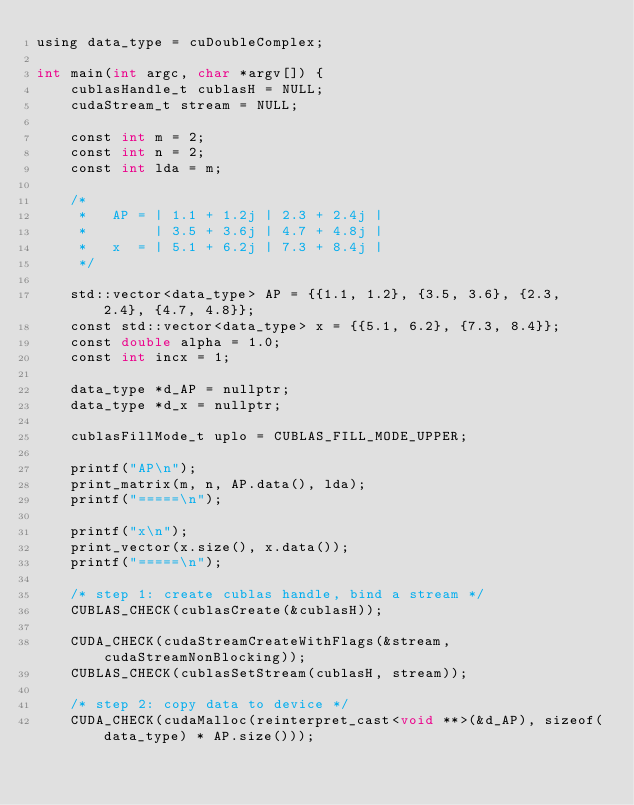Convert code to text. <code><loc_0><loc_0><loc_500><loc_500><_Cuda_>using data_type = cuDoubleComplex;

int main(int argc, char *argv[]) {
    cublasHandle_t cublasH = NULL;
    cudaStream_t stream = NULL;

    const int m = 2;
    const int n = 2;
    const int lda = m;

    /*
     *   AP = | 1.1 + 1.2j | 2.3 + 2.4j |
     *        | 3.5 + 3.6j | 4.7 + 4.8j |
     *   x  = | 5.1 + 6.2j | 7.3 + 8.4j |
     */

    std::vector<data_type> AP = {{1.1, 1.2}, {3.5, 3.6}, {2.3, 2.4}, {4.7, 4.8}};
    const std::vector<data_type> x = {{5.1, 6.2}, {7.3, 8.4}};
    const double alpha = 1.0;
    const int incx = 1;

    data_type *d_AP = nullptr;
    data_type *d_x = nullptr;

    cublasFillMode_t uplo = CUBLAS_FILL_MODE_UPPER;

    printf("AP\n");
    print_matrix(m, n, AP.data(), lda);
    printf("=====\n");

    printf("x\n");
    print_vector(x.size(), x.data());
    printf("=====\n");

    /* step 1: create cublas handle, bind a stream */
    CUBLAS_CHECK(cublasCreate(&cublasH));

    CUDA_CHECK(cudaStreamCreateWithFlags(&stream, cudaStreamNonBlocking));
    CUBLAS_CHECK(cublasSetStream(cublasH, stream));

    /* step 2: copy data to device */
    CUDA_CHECK(cudaMalloc(reinterpret_cast<void **>(&d_AP), sizeof(data_type) * AP.size()));</code> 